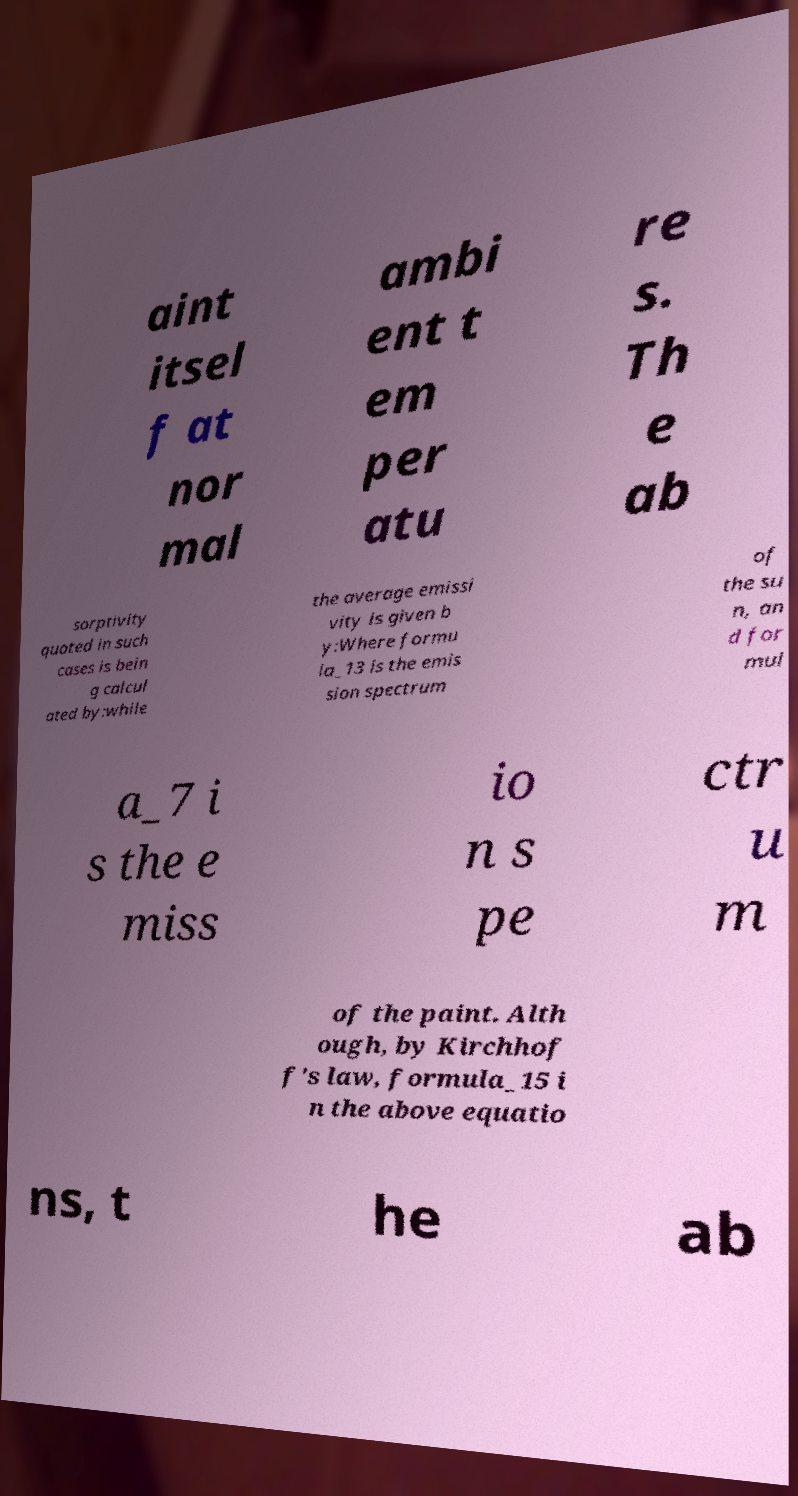Could you extract and type out the text from this image? aint itsel f at nor mal ambi ent t em per atu re s. Th e ab sorptivity quoted in such cases is bein g calcul ated by:while the average emissi vity is given b y:Where formu la_13 is the emis sion spectrum of the su n, an d for mul a_7 i s the e miss io n s pe ctr u m of the paint. Alth ough, by Kirchhof f's law, formula_15 i n the above equatio ns, t he ab 